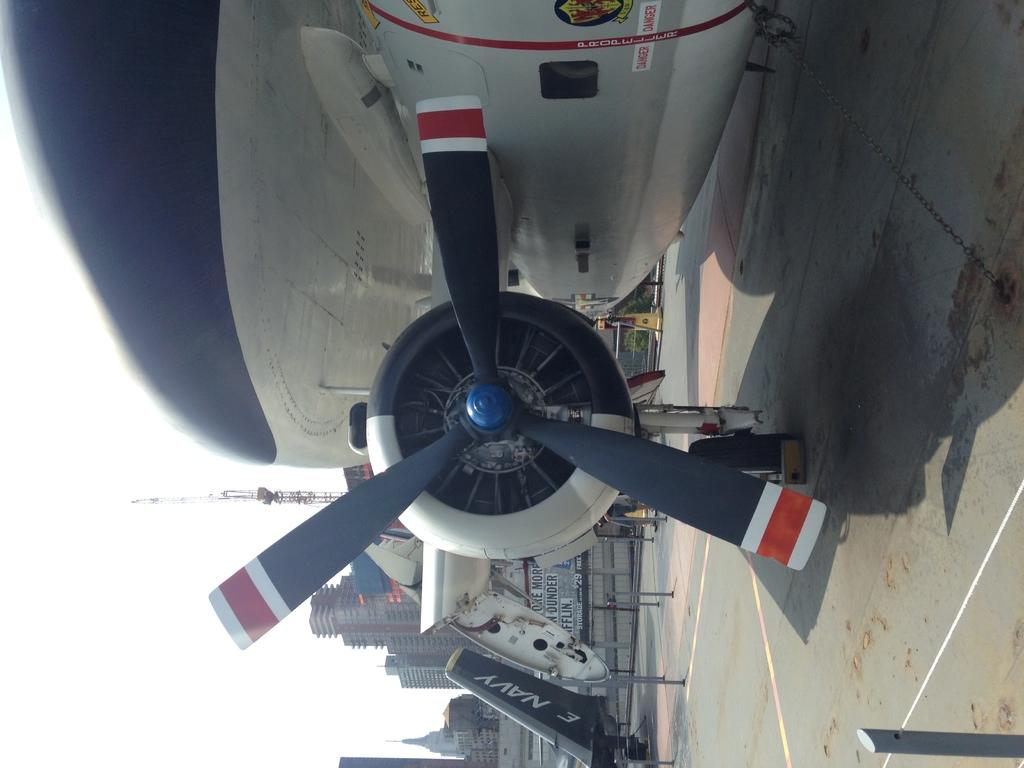<image>
Give a short and clear explanation of the subsequent image. the propeller of a navy plane leaves a large shadow 